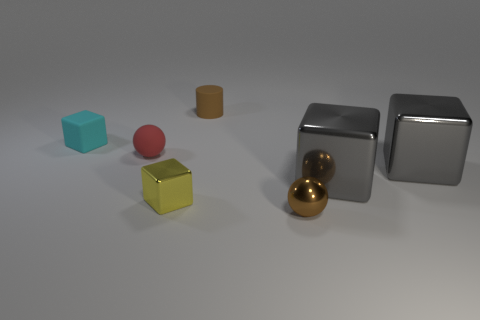Subtract all yellow metallic blocks. How many blocks are left? 3 Add 1 metal objects. How many objects exist? 8 Subtract all red balls. How many balls are left? 1 Subtract 1 balls. How many balls are left? 1 Subtract all cylinders. How many objects are left? 6 Subtract all blue cylinders. How many yellow blocks are left? 1 Subtract 0 purple spheres. How many objects are left? 7 Subtract all brown blocks. Subtract all blue spheres. How many blocks are left? 4 Subtract all tiny matte blocks. Subtract all rubber objects. How many objects are left? 3 Add 4 small yellow things. How many small yellow things are left? 5 